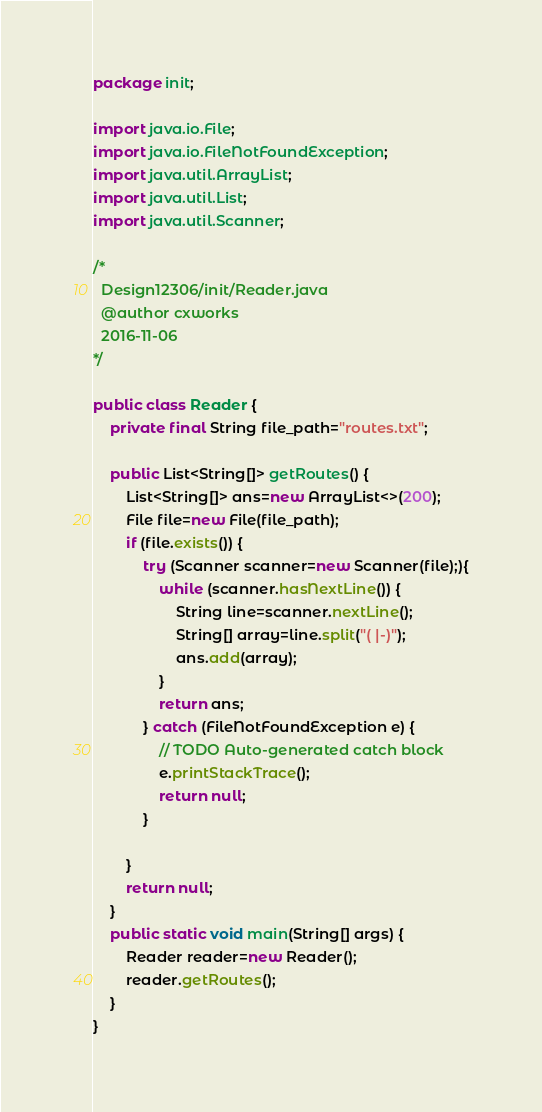Convert code to text. <code><loc_0><loc_0><loc_500><loc_500><_Java_>package init;

import java.io.File;
import java.io.FileNotFoundException;
import java.util.ArrayList;
import java.util.List;
import java.util.Scanner;

/*
  Design12306/init/Reader.java
  @author cxworks
  2016-11-06
*/

public class Reader {
	private final String file_path="routes.txt";
	
	public List<String[]> getRoutes() {
		List<String[]> ans=new ArrayList<>(200);
		File file=new File(file_path);
		if (file.exists()) {
			try (Scanner scanner=new Scanner(file);){
				while (scanner.hasNextLine()) {
					String line=scanner.nextLine();
					String[] array=line.split("( |-)");
					ans.add(array);
				}
				return ans;
			} catch (FileNotFoundException e) {
				// TODO Auto-generated catch block
				e.printStackTrace();
				return null;
			}
			
		}
		return null;
	}
	public static void main(String[] args) {
		Reader reader=new Reader();
		reader.getRoutes();
	}
}
</code> 